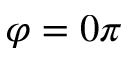Convert formula to latex. <formula><loc_0><loc_0><loc_500><loc_500>\varphi = 0 \pi</formula> 